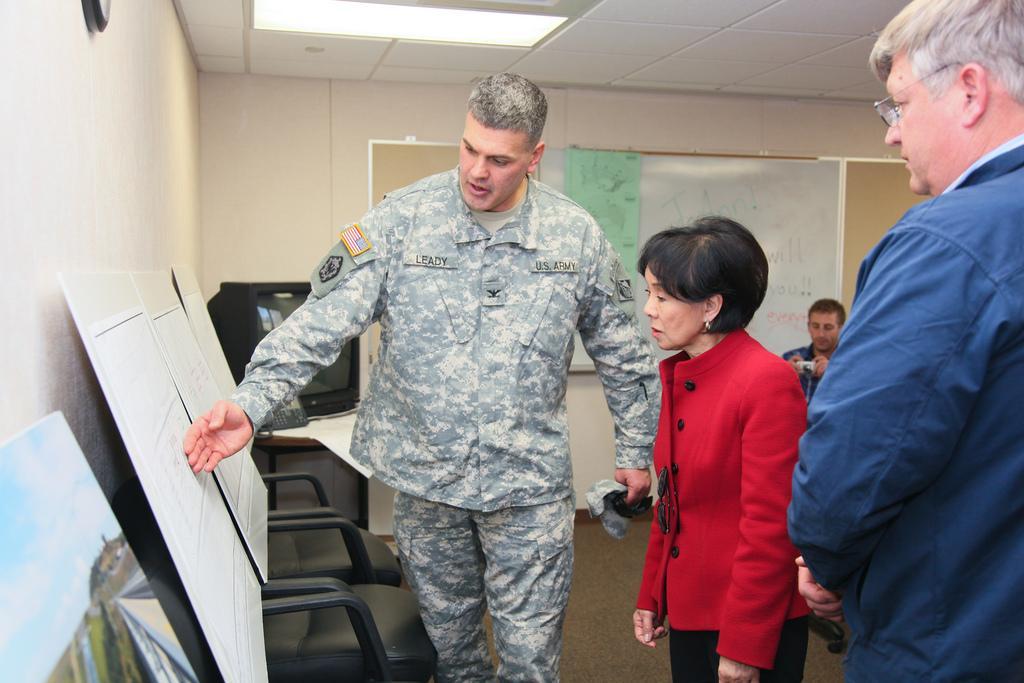Could you give a brief overview of what you see in this image? In this image there are people. There are display boards. There is a board on the wall in the background. On the left side, there is a wall. There is a carpet. There is a TV. 